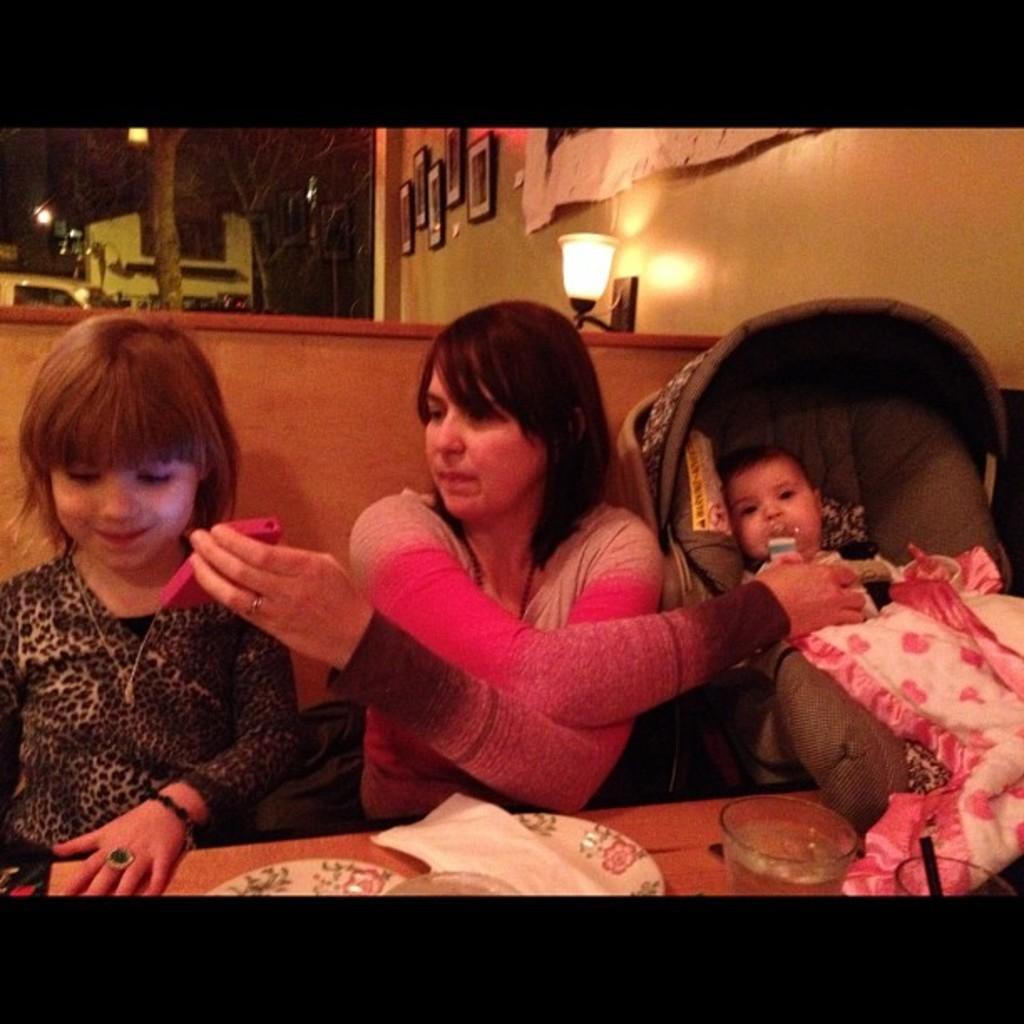In one or two sentences, can you explain what this image depicts? At the bottom of the image there is a table with plates, tissues and glass with liquid in it. Behind the table on the left side there is a girl standing with black dress. And in the middle there is lady with pink dress. On the right side of the image there is a stroller with a baby in it. At the top of the image on the right side there is a wall with lamp and frames. And on the left side of the image there are trees, buildings and lights. 